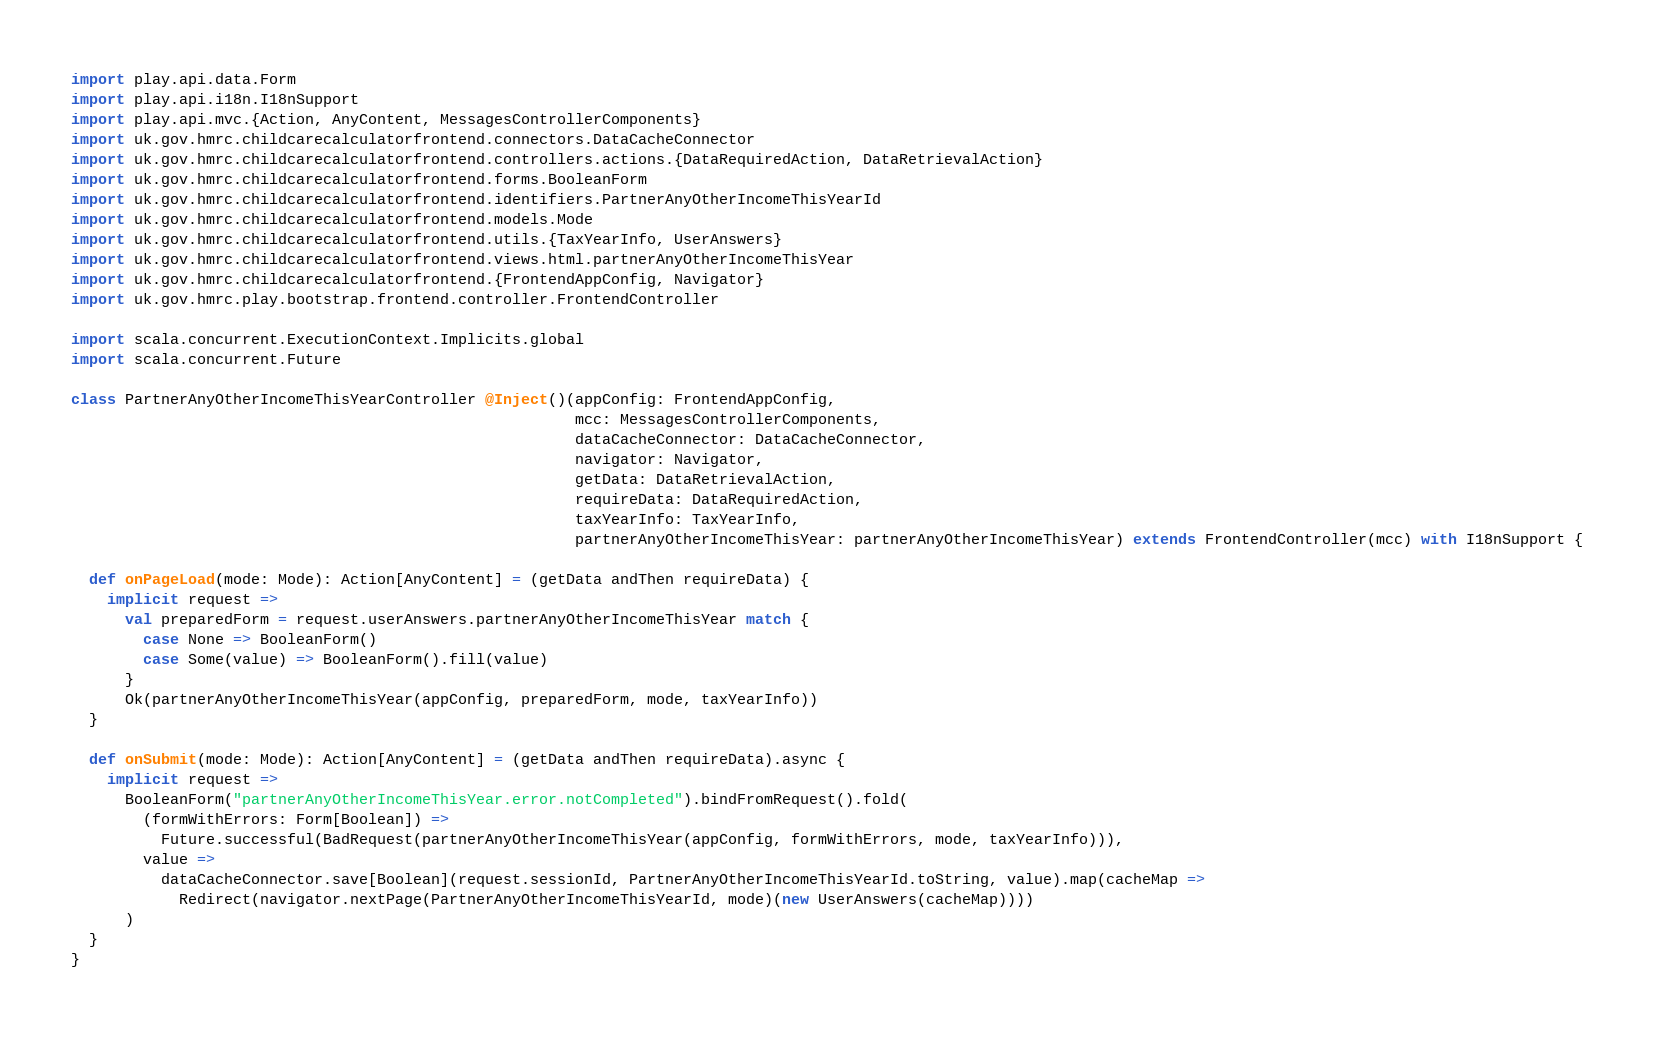<code> <loc_0><loc_0><loc_500><loc_500><_Scala_>import play.api.data.Form
import play.api.i18n.I18nSupport
import play.api.mvc.{Action, AnyContent, MessagesControllerComponents}
import uk.gov.hmrc.childcarecalculatorfrontend.connectors.DataCacheConnector
import uk.gov.hmrc.childcarecalculatorfrontend.controllers.actions.{DataRequiredAction, DataRetrievalAction}
import uk.gov.hmrc.childcarecalculatorfrontend.forms.BooleanForm
import uk.gov.hmrc.childcarecalculatorfrontend.identifiers.PartnerAnyOtherIncomeThisYearId
import uk.gov.hmrc.childcarecalculatorfrontend.models.Mode
import uk.gov.hmrc.childcarecalculatorfrontend.utils.{TaxYearInfo, UserAnswers}
import uk.gov.hmrc.childcarecalculatorfrontend.views.html.partnerAnyOtherIncomeThisYear
import uk.gov.hmrc.childcarecalculatorfrontend.{FrontendAppConfig, Navigator}
import uk.gov.hmrc.play.bootstrap.frontend.controller.FrontendController

import scala.concurrent.ExecutionContext.Implicits.global
import scala.concurrent.Future

class PartnerAnyOtherIncomeThisYearController @Inject()(appConfig: FrontendAppConfig,
                                                        mcc: MessagesControllerComponents,
                                                        dataCacheConnector: DataCacheConnector,
                                                        navigator: Navigator,
                                                        getData: DataRetrievalAction,
                                                        requireData: DataRequiredAction,
                                                        taxYearInfo: TaxYearInfo,
                                                        partnerAnyOtherIncomeThisYear: partnerAnyOtherIncomeThisYear) extends FrontendController(mcc) with I18nSupport {

  def onPageLoad(mode: Mode): Action[AnyContent] = (getData andThen requireData) {
    implicit request =>
      val preparedForm = request.userAnswers.partnerAnyOtherIncomeThisYear match {
        case None => BooleanForm()
        case Some(value) => BooleanForm().fill(value)
      }
      Ok(partnerAnyOtherIncomeThisYear(appConfig, preparedForm, mode, taxYearInfo))
  }

  def onSubmit(mode: Mode): Action[AnyContent] = (getData andThen requireData).async {
    implicit request =>
      BooleanForm("partnerAnyOtherIncomeThisYear.error.notCompleted").bindFromRequest().fold(
        (formWithErrors: Form[Boolean]) =>
          Future.successful(BadRequest(partnerAnyOtherIncomeThisYear(appConfig, formWithErrors, mode, taxYearInfo))),
        value =>
          dataCacheConnector.save[Boolean](request.sessionId, PartnerAnyOtherIncomeThisYearId.toString, value).map(cacheMap =>
            Redirect(navigator.nextPage(PartnerAnyOtherIncomeThisYearId, mode)(new UserAnswers(cacheMap))))
      )
  }
}
</code> 